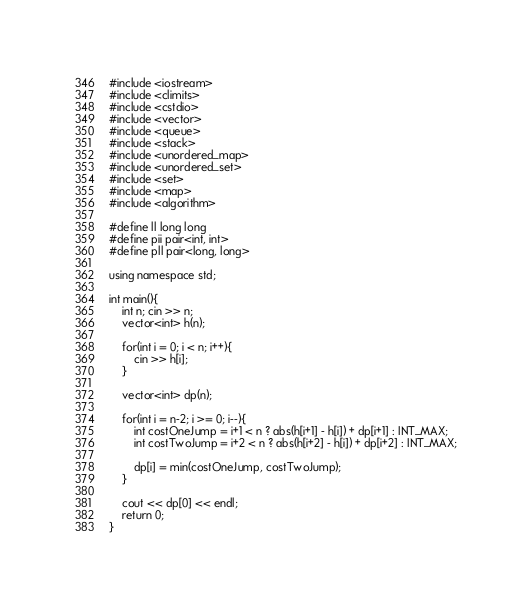Convert code to text. <code><loc_0><loc_0><loc_500><loc_500><_C++_>#include <iostream>
#include <climits>
#include <cstdio>
#include <vector>
#include <queue>
#include <stack>
#include <unordered_map>
#include <unordered_set>
#include <set>
#include <map>
#include <algorithm>

#define ll long long
#define pii pair<int, int>
#define pll pair<long, long>

using namespace std;

int main(){
	int n; cin >> n;
	vector<int> h(n); 

	for(int i = 0; i < n; i++){
		cin >> h[i];
	}	

	vector<int> dp(n);

	for(int i = n-2; i >= 0; i--){
		int costOneJump = i+1 < n ? abs(h[i+1] - h[i]) + dp[i+1] : INT_MAX;
		int costTwoJump = i+2 < n ? abs(h[i+2] - h[i]) + dp[i+2] : INT_MAX;

		dp[i] = min(costOneJump, costTwoJump);
	}

	cout << dp[0] << endl;
	return 0;
}</code> 